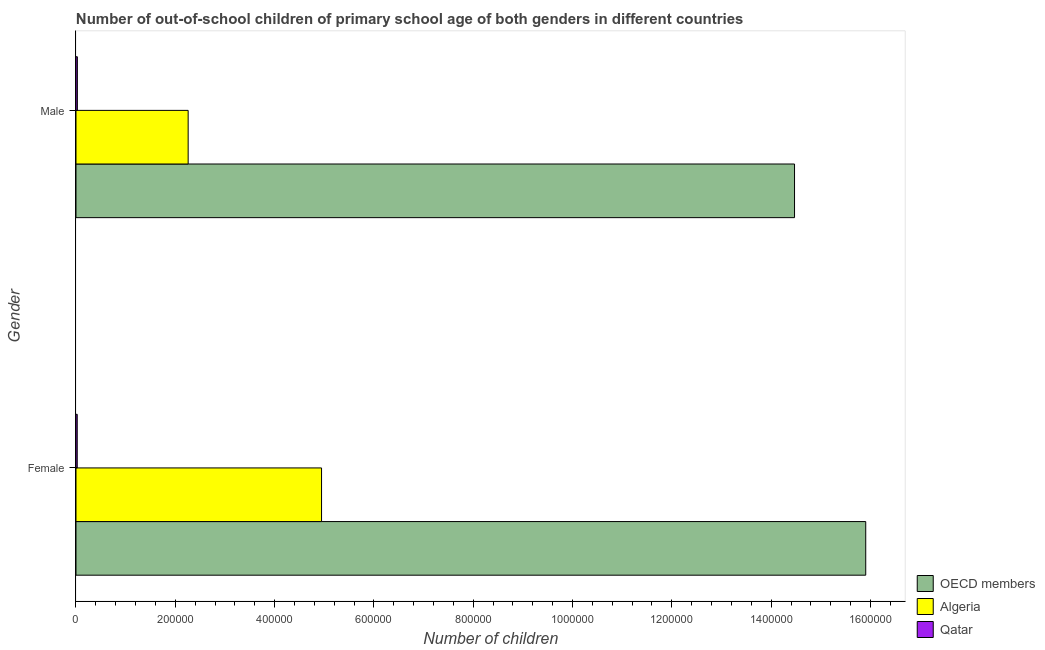Are the number of bars per tick equal to the number of legend labels?
Your answer should be very brief. Yes. How many bars are there on the 2nd tick from the top?
Make the answer very short. 3. How many bars are there on the 2nd tick from the bottom?
Make the answer very short. 3. What is the label of the 1st group of bars from the top?
Give a very brief answer. Male. What is the number of female out-of-school students in OECD members?
Give a very brief answer. 1.59e+06. Across all countries, what is the maximum number of male out-of-school students?
Provide a short and direct response. 1.45e+06. Across all countries, what is the minimum number of male out-of-school students?
Offer a terse response. 2785. In which country was the number of female out-of-school students minimum?
Your response must be concise. Qatar. What is the total number of male out-of-school students in the graph?
Provide a short and direct response. 1.68e+06. What is the difference between the number of male out-of-school students in Algeria and that in OECD members?
Offer a very short reply. -1.22e+06. What is the difference between the number of female out-of-school students in OECD members and the number of male out-of-school students in Algeria?
Offer a very short reply. 1.36e+06. What is the average number of male out-of-school students per country?
Your response must be concise. 5.59e+05. What is the difference between the number of female out-of-school students and number of male out-of-school students in Algeria?
Make the answer very short. 2.69e+05. In how many countries, is the number of male out-of-school students greater than 800000 ?
Your answer should be very brief. 1. What is the ratio of the number of male out-of-school students in Qatar to that in OECD members?
Your answer should be compact. 0. Is the number of male out-of-school students in Qatar less than that in Algeria?
Your answer should be very brief. Yes. In how many countries, is the number of female out-of-school students greater than the average number of female out-of-school students taken over all countries?
Make the answer very short. 1. What does the 1st bar from the top in Male represents?
Give a very brief answer. Qatar. What does the 1st bar from the bottom in Female represents?
Your answer should be compact. OECD members. Are all the bars in the graph horizontal?
Give a very brief answer. Yes. Are the values on the major ticks of X-axis written in scientific E-notation?
Make the answer very short. No. Does the graph contain any zero values?
Give a very brief answer. No. Does the graph contain grids?
Provide a succinct answer. No. Where does the legend appear in the graph?
Make the answer very short. Bottom right. What is the title of the graph?
Provide a succinct answer. Number of out-of-school children of primary school age of both genders in different countries. What is the label or title of the X-axis?
Keep it short and to the point. Number of children. What is the Number of children of OECD members in Female?
Provide a short and direct response. 1.59e+06. What is the Number of children of Algeria in Female?
Your response must be concise. 4.95e+05. What is the Number of children in Qatar in Female?
Your answer should be very brief. 2502. What is the Number of children in OECD members in Male?
Keep it short and to the point. 1.45e+06. What is the Number of children of Algeria in Male?
Your answer should be very brief. 2.26e+05. What is the Number of children of Qatar in Male?
Your answer should be compact. 2785. Across all Gender, what is the maximum Number of children of OECD members?
Offer a very short reply. 1.59e+06. Across all Gender, what is the maximum Number of children in Algeria?
Your answer should be very brief. 4.95e+05. Across all Gender, what is the maximum Number of children in Qatar?
Offer a very short reply. 2785. Across all Gender, what is the minimum Number of children in OECD members?
Your answer should be very brief. 1.45e+06. Across all Gender, what is the minimum Number of children of Algeria?
Your response must be concise. 2.26e+05. Across all Gender, what is the minimum Number of children of Qatar?
Keep it short and to the point. 2502. What is the total Number of children of OECD members in the graph?
Make the answer very short. 3.04e+06. What is the total Number of children in Algeria in the graph?
Offer a very short reply. 7.20e+05. What is the total Number of children in Qatar in the graph?
Ensure brevity in your answer.  5287. What is the difference between the Number of children in OECD members in Female and that in Male?
Offer a very short reply. 1.43e+05. What is the difference between the Number of children in Algeria in Female and that in Male?
Make the answer very short. 2.69e+05. What is the difference between the Number of children in Qatar in Female and that in Male?
Give a very brief answer. -283. What is the difference between the Number of children in OECD members in Female and the Number of children in Algeria in Male?
Give a very brief answer. 1.36e+06. What is the difference between the Number of children in OECD members in Female and the Number of children in Qatar in Male?
Give a very brief answer. 1.59e+06. What is the difference between the Number of children of Algeria in Female and the Number of children of Qatar in Male?
Offer a terse response. 4.92e+05. What is the average Number of children in OECD members per Gender?
Make the answer very short. 1.52e+06. What is the average Number of children in Algeria per Gender?
Give a very brief answer. 3.60e+05. What is the average Number of children of Qatar per Gender?
Make the answer very short. 2643.5. What is the difference between the Number of children in OECD members and Number of children in Algeria in Female?
Provide a short and direct response. 1.10e+06. What is the difference between the Number of children of OECD members and Number of children of Qatar in Female?
Give a very brief answer. 1.59e+06. What is the difference between the Number of children in Algeria and Number of children in Qatar in Female?
Keep it short and to the point. 4.92e+05. What is the difference between the Number of children of OECD members and Number of children of Algeria in Male?
Make the answer very short. 1.22e+06. What is the difference between the Number of children in OECD members and Number of children in Qatar in Male?
Your response must be concise. 1.44e+06. What is the difference between the Number of children of Algeria and Number of children of Qatar in Male?
Provide a succinct answer. 2.23e+05. What is the ratio of the Number of children in OECD members in Female to that in Male?
Ensure brevity in your answer.  1.1. What is the ratio of the Number of children of Algeria in Female to that in Male?
Give a very brief answer. 2.19. What is the ratio of the Number of children of Qatar in Female to that in Male?
Offer a terse response. 0.9. What is the difference between the highest and the second highest Number of children of OECD members?
Offer a terse response. 1.43e+05. What is the difference between the highest and the second highest Number of children in Algeria?
Give a very brief answer. 2.69e+05. What is the difference between the highest and the second highest Number of children of Qatar?
Your answer should be very brief. 283. What is the difference between the highest and the lowest Number of children of OECD members?
Provide a succinct answer. 1.43e+05. What is the difference between the highest and the lowest Number of children in Algeria?
Provide a short and direct response. 2.69e+05. What is the difference between the highest and the lowest Number of children in Qatar?
Your response must be concise. 283. 